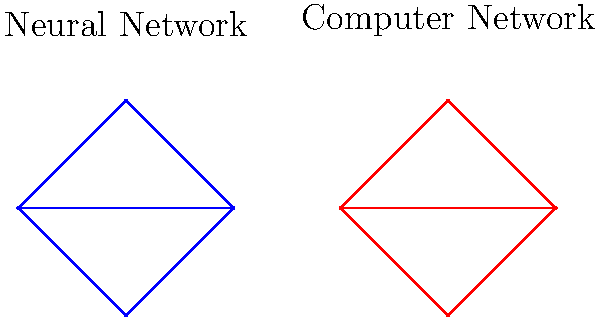In the diagram above, which structural similarity between neural networks and computer networks makes the human brain potentially vulnerable to cyber-attacks, and how might this be exploited? To answer this question, we need to analyze the structural similarities between neural networks and computer networks, and consider their implications for brain vulnerabilities:

1. Interconnected nodes: Both networks show interconnected nodes (neurons in the brain, computers in the network).

2. Information flow: Both systems rely on connections between nodes to transmit information (synapses in the brain, network connections in computer systems).

3. Hierarchical structure: Both networks display a hierarchical arrangement of nodes, with some nodes serving as central hubs.

4. Distributed processing: Information is processed across multiple nodes in both systems.

5. Adaptability: Both networks can adapt and reconfigure based on input and learning (neuroplasticity in the brain, dynamic routing in computer networks).

The key vulnerability arises from the interconnected nature of both systems. In computer networks, this allows for the propagation of malware or unauthorized access. Similarly, in the brain, this interconnectedness could potentially be exploited by:

a) Manipulating sensory inputs to influence neural pathways
b) Overloading specific neural circuits to disrupt normal brain function
c) Exploiting the brain's plasticity to introduce false memories or alter decision-making processes

A potential exploit could involve using electromagnetic pulses or carefully crafted sensory stimuli to manipulate neural activity, similar to how hackers might use network packets to compromise computer systems.
Answer: Interconnected node structure allows for propagation of malicious inputs 